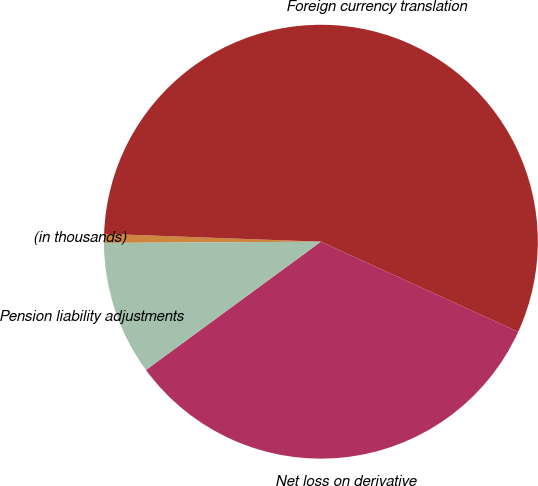Convert chart to OTSL. <chart><loc_0><loc_0><loc_500><loc_500><pie_chart><fcel>(in thousands)<fcel>Foreign currency translation<fcel>Net loss on derivative<fcel>Pension liability adjustments<nl><fcel>0.67%<fcel>56.24%<fcel>33.11%<fcel>9.98%<nl></chart> 